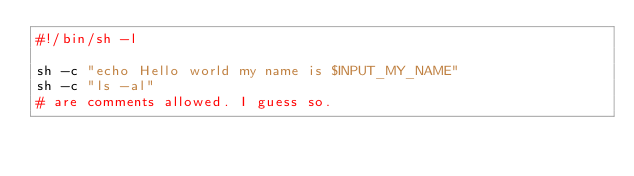<code> <loc_0><loc_0><loc_500><loc_500><_Bash_>#!/bin/sh -l

sh -c "echo Hello world my name is $INPUT_MY_NAME"
sh -c "ls -al"
# are comments allowed. I guess so.
</code> 